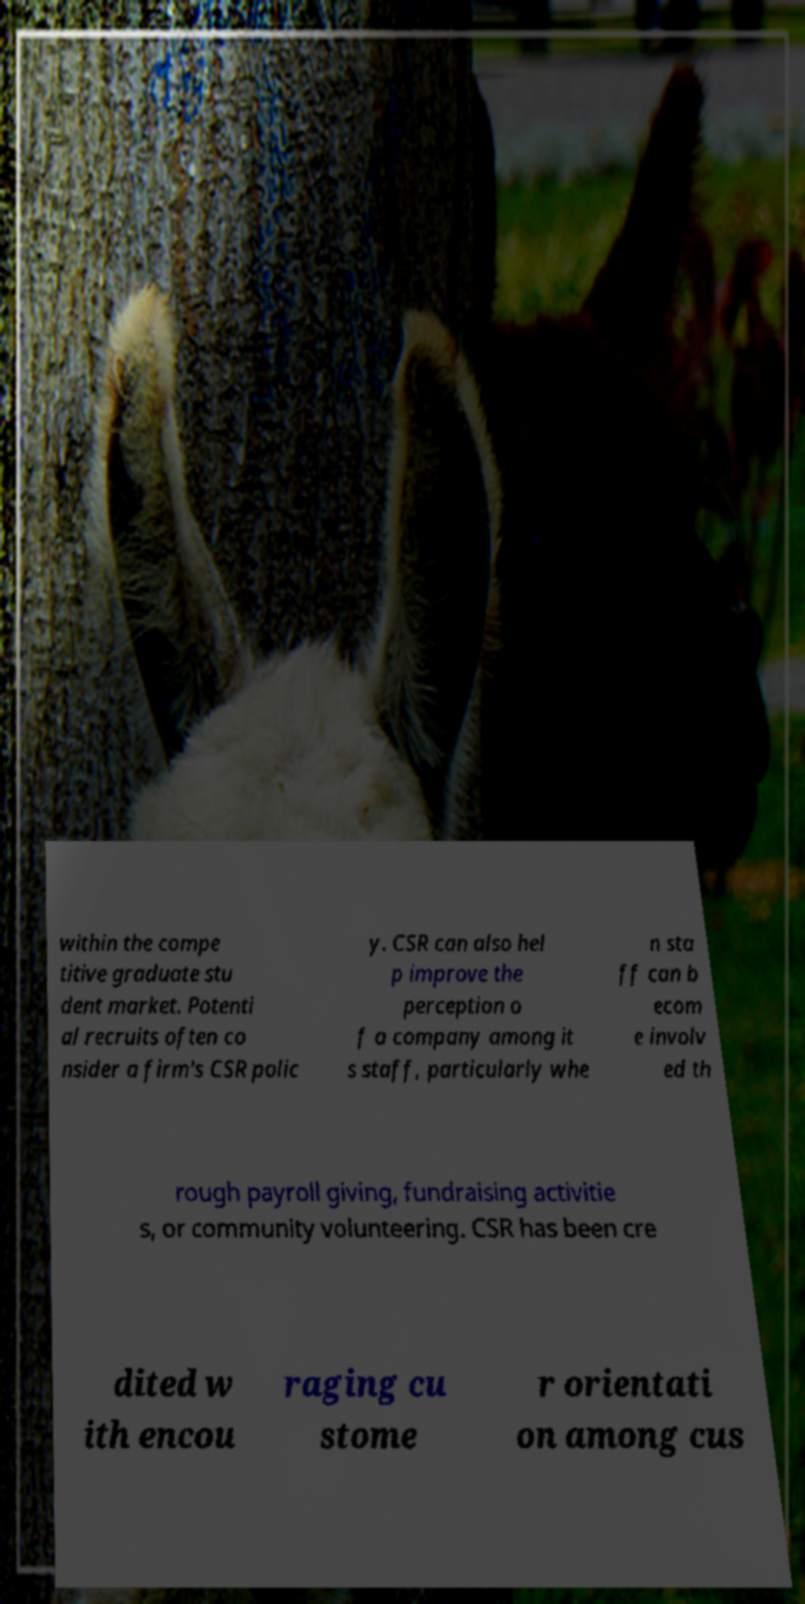Could you assist in decoding the text presented in this image and type it out clearly? within the compe titive graduate stu dent market. Potenti al recruits often co nsider a firm's CSR polic y. CSR can also hel p improve the perception o f a company among it s staff, particularly whe n sta ff can b ecom e involv ed th rough payroll giving, fundraising activitie s, or community volunteering. CSR has been cre dited w ith encou raging cu stome r orientati on among cus 